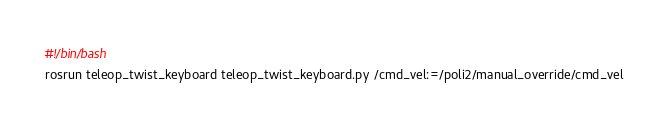Convert code to text. <code><loc_0><loc_0><loc_500><loc_500><_Bash_>#!/bin/bash 
rosrun teleop_twist_keyboard teleop_twist_keyboard.py /cmd_vel:=/poli2/manual_override/cmd_vel</code> 